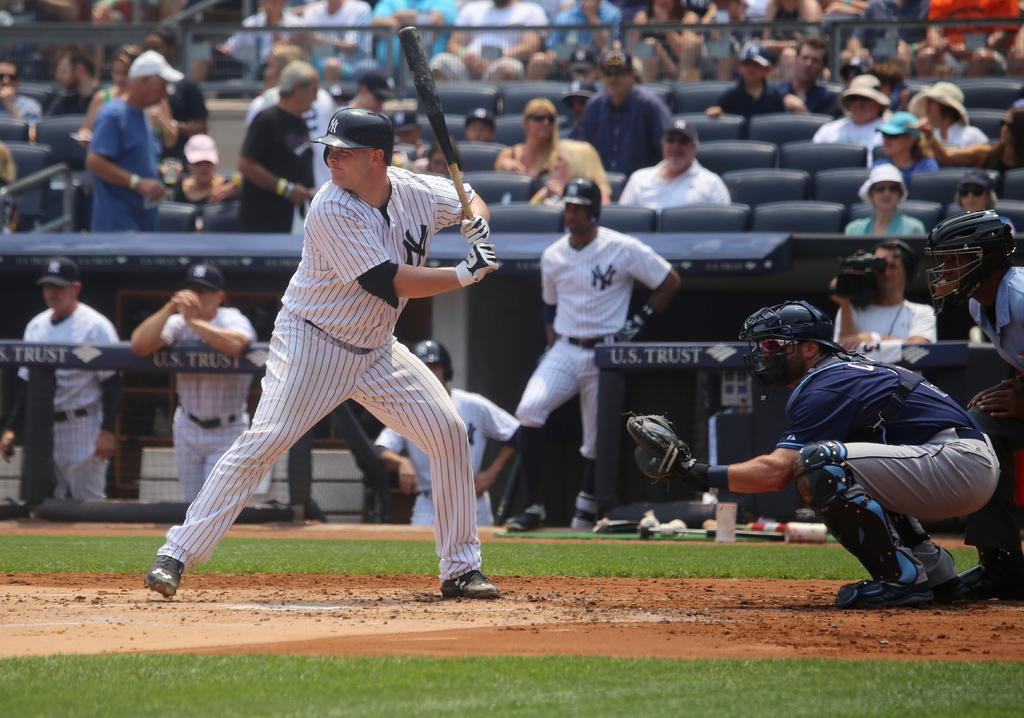Provide a one-sentence caption for the provided image. A Yankee's players squares up at home plate. 